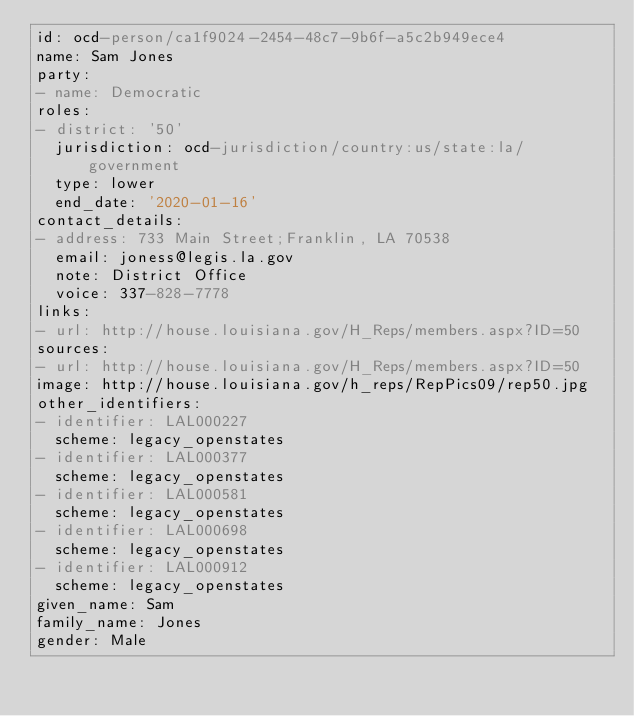<code> <loc_0><loc_0><loc_500><loc_500><_YAML_>id: ocd-person/ca1f9024-2454-48c7-9b6f-a5c2b949ece4
name: Sam Jones
party:
- name: Democratic
roles:
- district: '50'
  jurisdiction: ocd-jurisdiction/country:us/state:la/government
  type: lower
  end_date: '2020-01-16'
contact_details:
- address: 733 Main Street;Franklin, LA 70538
  email: joness@legis.la.gov
  note: District Office
  voice: 337-828-7778
links:
- url: http://house.louisiana.gov/H_Reps/members.aspx?ID=50
sources:
- url: http://house.louisiana.gov/H_Reps/members.aspx?ID=50
image: http://house.louisiana.gov/h_reps/RepPics09/rep50.jpg
other_identifiers:
- identifier: LAL000227
  scheme: legacy_openstates
- identifier: LAL000377
  scheme: legacy_openstates
- identifier: LAL000581
  scheme: legacy_openstates
- identifier: LAL000698
  scheme: legacy_openstates
- identifier: LAL000912
  scheme: legacy_openstates
given_name: Sam
family_name: Jones
gender: Male
</code> 